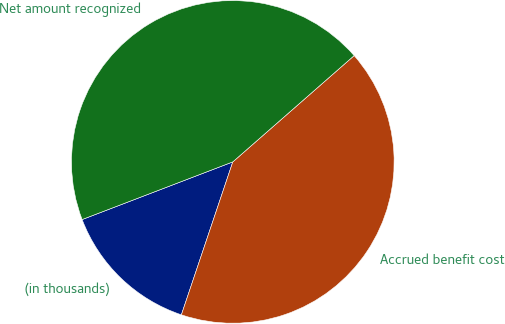Convert chart to OTSL. <chart><loc_0><loc_0><loc_500><loc_500><pie_chart><fcel>(in thousands)<fcel>Accrued benefit cost<fcel>Net amount recognized<nl><fcel>14.02%<fcel>41.61%<fcel>44.37%<nl></chart> 